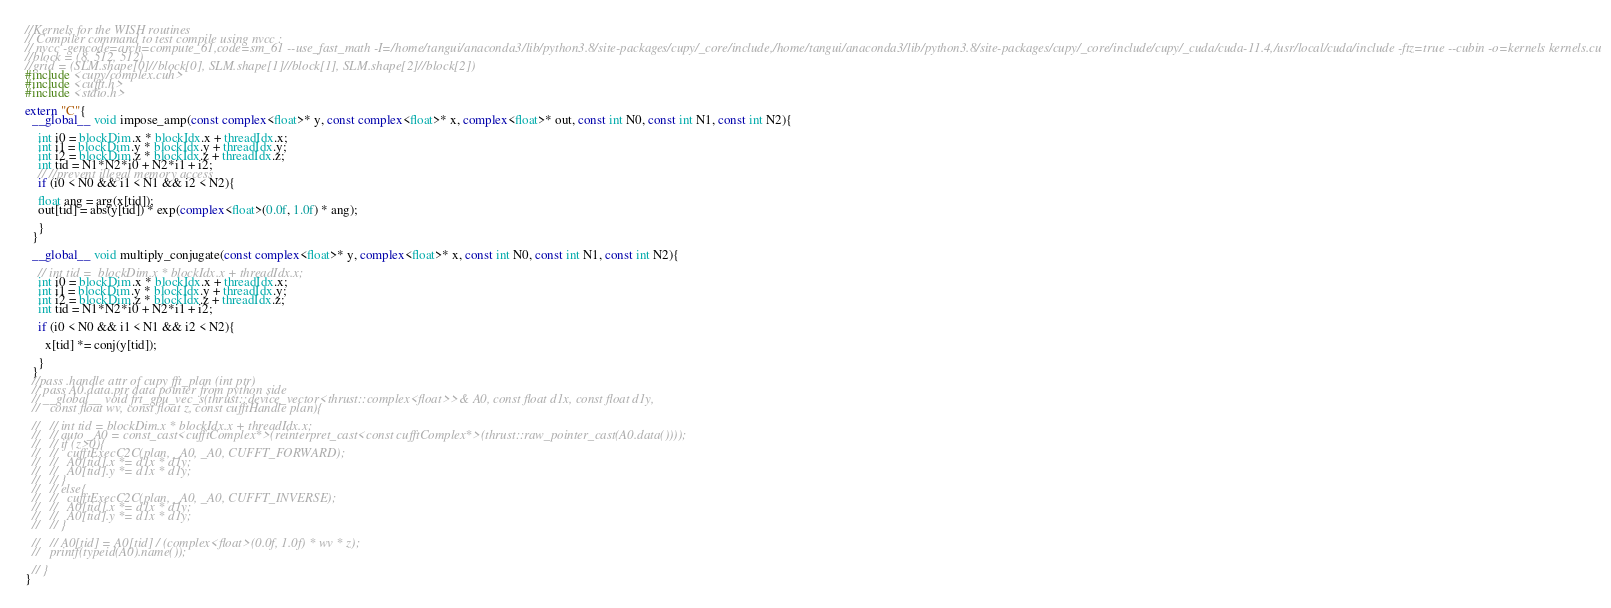Convert code to text. <code><loc_0><loc_0><loc_500><loc_500><_Cuda_>//Kernels for the WISH routines
// Compiler command to test compile using nvcc :
// nvcc -gencode=arch=compute_61,code=sm_61 --use_fast_math -I=/home/tangui/anaconda3/lib/python3.8/site-packages/cupy/_core/include,/home/tangui/anaconda3/lib/python3.8/site-packages/cupy/_core/include/cupy/_cuda/cuda-11.4,/usr/local/cuda/include -ftz=true --cubin -o=kernels kernels.cu
//block = (8, 512, 512)
//grid = (SLM.shape[0]//block[0], SLM.shape[1]//block[1], SLM.shape[2]//block[2])
#include <cupy/complex.cuh>
#include <cufft.h>
#include <stdio.h>

extern "C"{
  __global__ void impose_amp(const complex<float>* y, const complex<float>* x, complex<float>* out, const int N0, const int N1, const int N2){

    int i0 = blockDim.x * blockIdx.x + threadIdx.x;
    int i1 = blockDim.y * blockIdx.y + threadIdx.y;
    int i2 = blockDim.z * blockIdx.z + threadIdx.z;
    int tid = N1*N2*i0 + N2*i1 + i2;
    // //prevent illegal memory access
    if (i0 < N0 && i1 < N1 && i2 < N2){
        
    float ang = arg(x[tid]);
    out[tid] = abs(y[tid]) * exp(complex<float>(0.0f, 1.0f) * ang);
    
    }
  }

  __global__ void multiply_conjugate(const complex<float>* y, complex<float>* x, const int N0, const int N1, const int N2){

    // int tid =  blockDim.x * blockIdx.x + threadIdx.x;
    int i0 = blockDim.x * blockIdx.x + threadIdx.x;
    int i1 = blockDim.y * blockIdx.y + threadIdx.y;
    int i2 = blockDim.z * blockIdx.z + threadIdx.z;
    int tid = N1*N2*i0 + N2*i1 + i2;
    
    if (i0 < N0 && i1 < N1 && i2 < N2){
    
      x[tid] *= conj(y[tid]);
    
    }
  }
  //pass .handle attr of cupy fft_plan (int ptr)
  // pass A0.data.ptr data pointer from python side
  // __global__ void frt_gpu_vec_s(thrust::device_vector<thrust::complex<float>>& A0, const float d1x, const float d1y,
  //   const float wv, const float z, const cufftHandle plan){

  //   // int tid = blockDim.x * blockIdx.x + threadIdx.x;
  //   // auto _A0 = const_cast<cufftComplex*>(reinterpret_cast<const cufftComplex*>(thrust::raw_pointer_cast(A0.data())));
  //   // if (z>0){
  //   //   cufftExecC2C(plan, _A0, _A0, CUFFT_FORWARD);
  //   //   A0[tid].x *= d1x * d1y;
  //   //   A0[tid].y *= d1x * d1y;
  //   // }
  //   // else{
  //   //   cufftExecC2C(plan, _A0, _A0, CUFFT_INVERSE);
  //   //   A0[tid].x *= d1x * d1y;
  //   //   A0[tid].y *= d1x * d1y;
  //   // }
    
  //   // A0[tid] = A0[tid] / (complex<float>(0.0f, 1.0f) * wv * z);
  //   printf(typeid(A0).name());

  // }
}
</code> 